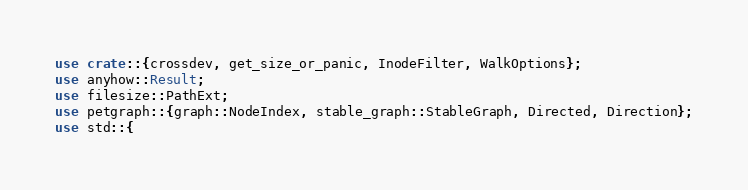Convert code to text. <code><loc_0><loc_0><loc_500><loc_500><_Rust_>use crate::{crossdev, get_size_or_panic, InodeFilter, WalkOptions};
use anyhow::Result;
use filesize::PathExt;
use petgraph::{graph::NodeIndex, stable_graph::StableGraph, Directed, Direction};
use std::{</code> 